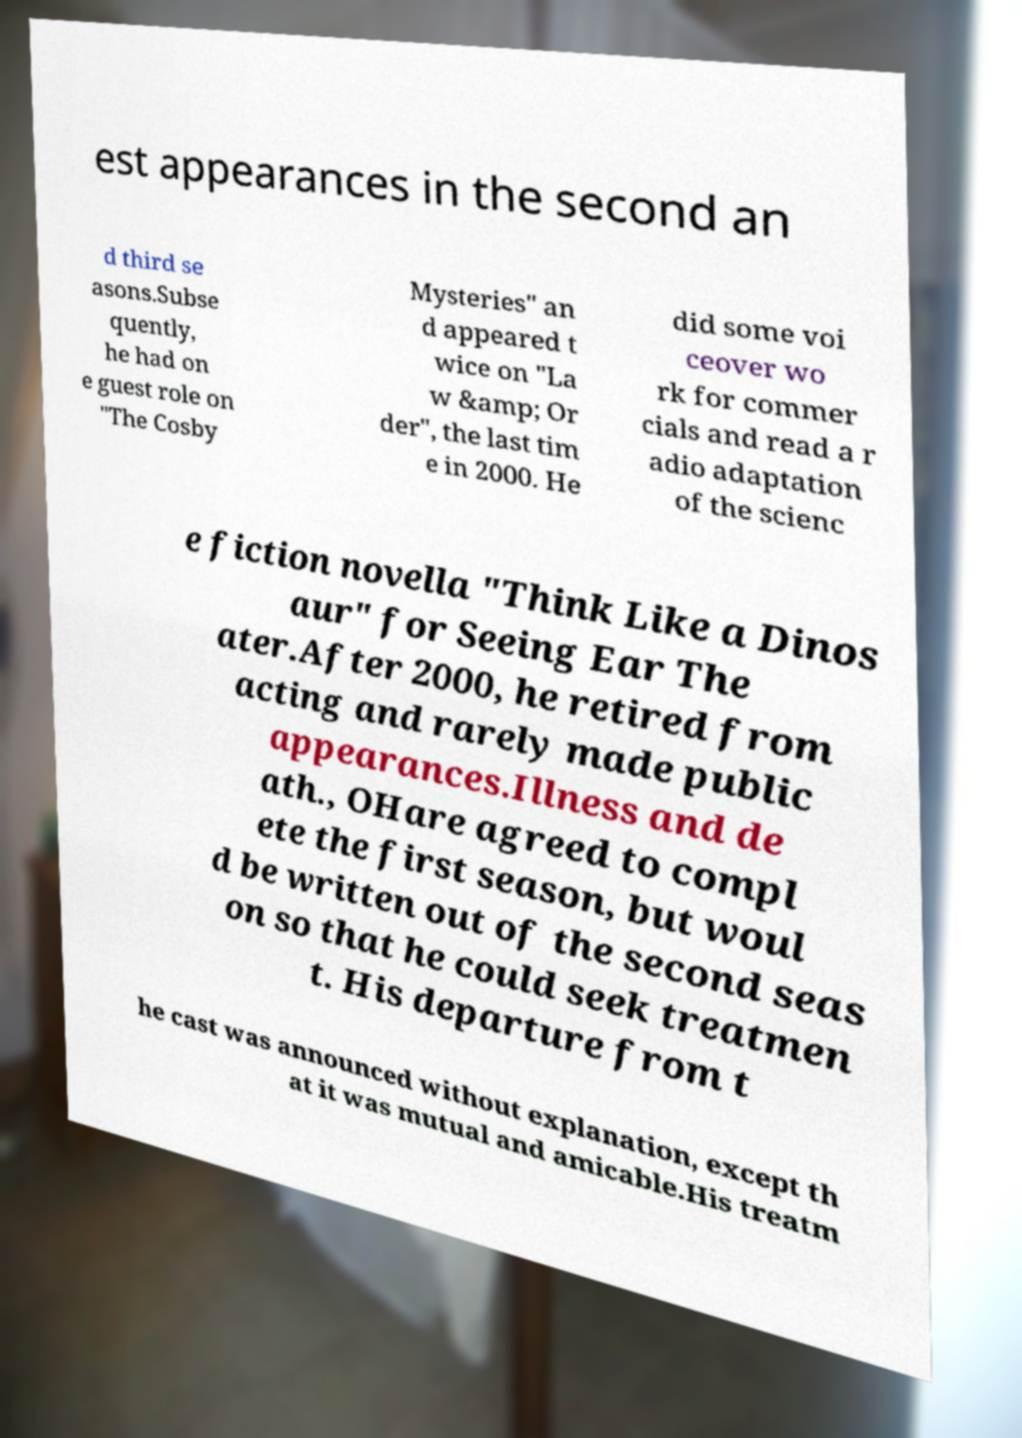Please read and relay the text visible in this image. What does it say? est appearances in the second an d third se asons.Subse quently, he had on e guest role on "The Cosby Mysteries" an d appeared t wice on "La w &amp; Or der", the last tim e in 2000. He did some voi ceover wo rk for commer cials and read a r adio adaptation of the scienc e fiction novella "Think Like a Dinos aur" for Seeing Ear The ater.After 2000, he retired from acting and rarely made public appearances.Illness and de ath., OHare agreed to compl ete the first season, but woul d be written out of the second seas on so that he could seek treatmen t. His departure from t he cast was announced without explanation, except th at it was mutual and amicable.His treatm 